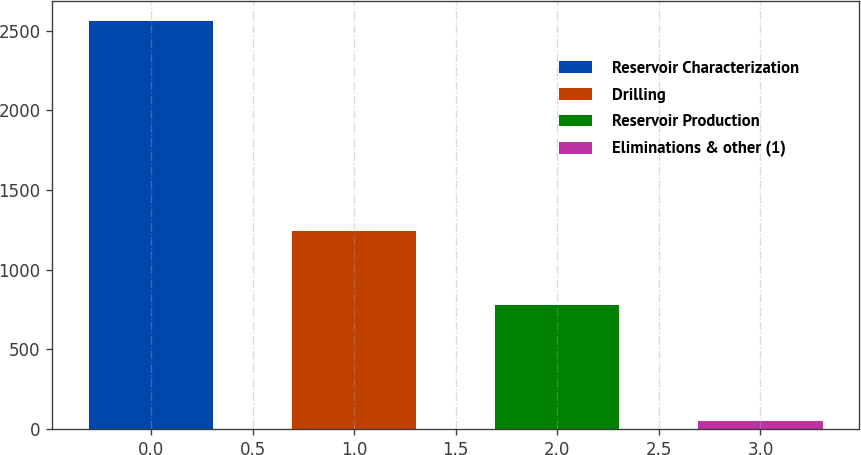Convert chart to OTSL. <chart><loc_0><loc_0><loc_500><loc_500><bar_chart><fcel>Reservoir Characterization<fcel>Drilling<fcel>Reservoir Production<fcel>Eliminations & other (1)<nl><fcel>2559<fcel>1245<fcel>780<fcel>51<nl></chart> 